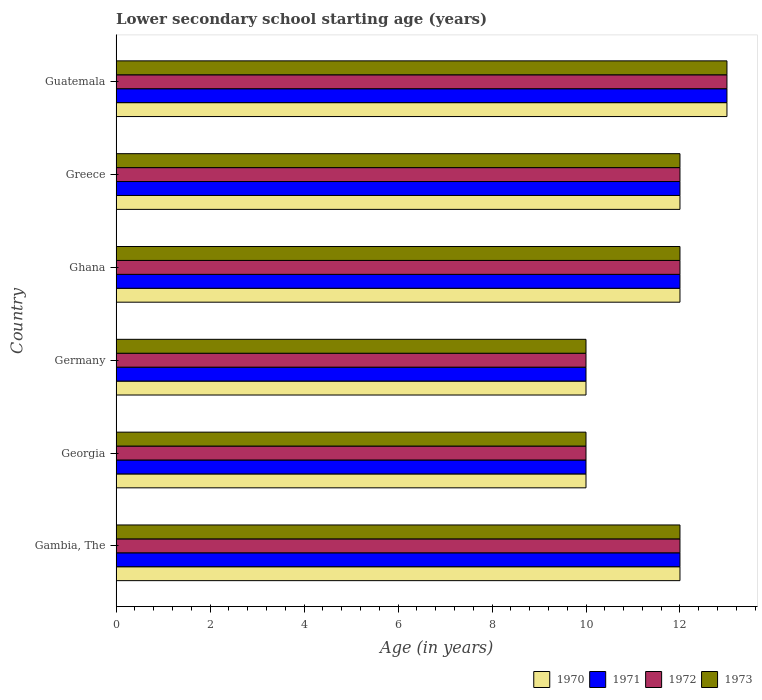How many different coloured bars are there?
Ensure brevity in your answer.  4. Are the number of bars per tick equal to the number of legend labels?
Offer a very short reply. Yes. Are the number of bars on each tick of the Y-axis equal?
Keep it short and to the point. Yes. How many bars are there on the 6th tick from the top?
Offer a terse response. 4. In how many cases, is the number of bars for a given country not equal to the number of legend labels?
Provide a short and direct response. 0. What is the lower secondary school starting age of children in 1970 in Germany?
Your answer should be compact. 10. Across all countries, what is the maximum lower secondary school starting age of children in 1973?
Make the answer very short. 13. Across all countries, what is the minimum lower secondary school starting age of children in 1971?
Keep it short and to the point. 10. In which country was the lower secondary school starting age of children in 1972 maximum?
Provide a short and direct response. Guatemala. In which country was the lower secondary school starting age of children in 1970 minimum?
Give a very brief answer. Georgia. What is the total lower secondary school starting age of children in 1972 in the graph?
Your answer should be compact. 69. What is the difference between the lower secondary school starting age of children in 1970 in Gambia, The and that in Guatemala?
Provide a short and direct response. -1. What is the difference between the lower secondary school starting age of children in 1973 in Georgia and the lower secondary school starting age of children in 1970 in Gambia, The?
Provide a succinct answer. -2. What is the ratio of the lower secondary school starting age of children in 1972 in Ghana to that in Guatemala?
Your response must be concise. 0.92. Is the difference between the lower secondary school starting age of children in 1973 in Germany and Greece greater than the difference between the lower secondary school starting age of children in 1971 in Germany and Greece?
Provide a succinct answer. No. Is the sum of the lower secondary school starting age of children in 1973 in Gambia, The and Ghana greater than the maximum lower secondary school starting age of children in 1970 across all countries?
Ensure brevity in your answer.  Yes. Is it the case that in every country, the sum of the lower secondary school starting age of children in 1972 and lower secondary school starting age of children in 1971 is greater than the lower secondary school starting age of children in 1970?
Provide a succinct answer. Yes. Are all the bars in the graph horizontal?
Ensure brevity in your answer.  Yes. Does the graph contain grids?
Give a very brief answer. No. How many legend labels are there?
Offer a very short reply. 4. What is the title of the graph?
Make the answer very short. Lower secondary school starting age (years). Does "1992" appear as one of the legend labels in the graph?
Keep it short and to the point. No. What is the label or title of the X-axis?
Keep it short and to the point. Age (in years). What is the label or title of the Y-axis?
Your answer should be very brief. Country. What is the Age (in years) in 1970 in Gambia, The?
Your answer should be compact. 12. What is the Age (in years) in 1972 in Gambia, The?
Offer a terse response. 12. What is the Age (in years) of 1970 in Georgia?
Your response must be concise. 10. What is the Age (in years) of 1971 in Georgia?
Give a very brief answer. 10. What is the Age (in years) of 1970 in Germany?
Provide a succinct answer. 10. What is the Age (in years) in 1973 in Ghana?
Provide a succinct answer. 12. What is the Age (in years) of 1972 in Greece?
Provide a short and direct response. 12. What is the Age (in years) of 1971 in Guatemala?
Give a very brief answer. 13. What is the Age (in years) in 1972 in Guatemala?
Offer a terse response. 13. What is the Age (in years) in 1973 in Guatemala?
Your answer should be compact. 13. Across all countries, what is the maximum Age (in years) in 1970?
Give a very brief answer. 13. Across all countries, what is the maximum Age (in years) of 1973?
Your response must be concise. 13. Across all countries, what is the minimum Age (in years) in 1972?
Provide a short and direct response. 10. What is the total Age (in years) in 1970 in the graph?
Give a very brief answer. 69. What is the total Age (in years) in 1971 in the graph?
Make the answer very short. 69. What is the total Age (in years) of 1972 in the graph?
Offer a very short reply. 69. What is the total Age (in years) of 1973 in the graph?
Provide a succinct answer. 69. What is the difference between the Age (in years) in 1970 in Gambia, The and that in Georgia?
Offer a terse response. 2. What is the difference between the Age (in years) in 1971 in Gambia, The and that in Georgia?
Make the answer very short. 2. What is the difference between the Age (in years) in 1972 in Gambia, The and that in Georgia?
Provide a short and direct response. 2. What is the difference between the Age (in years) of 1973 in Gambia, The and that in Georgia?
Provide a succinct answer. 2. What is the difference between the Age (in years) of 1970 in Gambia, The and that in Germany?
Your response must be concise. 2. What is the difference between the Age (in years) in 1971 in Gambia, The and that in Germany?
Ensure brevity in your answer.  2. What is the difference between the Age (in years) in 1973 in Gambia, The and that in Germany?
Offer a very short reply. 2. What is the difference between the Age (in years) in 1970 in Gambia, The and that in Ghana?
Give a very brief answer. 0. What is the difference between the Age (in years) of 1971 in Gambia, The and that in Ghana?
Provide a short and direct response. 0. What is the difference between the Age (in years) in 1970 in Gambia, The and that in Greece?
Offer a terse response. 0. What is the difference between the Age (in years) in 1970 in Gambia, The and that in Guatemala?
Give a very brief answer. -1. What is the difference between the Age (in years) of 1972 in Gambia, The and that in Guatemala?
Your answer should be compact. -1. What is the difference between the Age (in years) in 1970 in Georgia and that in Germany?
Provide a short and direct response. 0. What is the difference between the Age (in years) in 1971 in Georgia and that in Germany?
Offer a terse response. 0. What is the difference between the Age (in years) of 1970 in Georgia and that in Ghana?
Your answer should be very brief. -2. What is the difference between the Age (in years) in 1972 in Georgia and that in Ghana?
Your answer should be very brief. -2. What is the difference between the Age (in years) of 1970 in Georgia and that in Greece?
Ensure brevity in your answer.  -2. What is the difference between the Age (in years) of 1971 in Georgia and that in Greece?
Provide a succinct answer. -2. What is the difference between the Age (in years) of 1972 in Georgia and that in Greece?
Offer a very short reply. -2. What is the difference between the Age (in years) of 1973 in Georgia and that in Greece?
Keep it short and to the point. -2. What is the difference between the Age (in years) of 1970 in Georgia and that in Guatemala?
Provide a short and direct response. -3. What is the difference between the Age (in years) of 1971 in Georgia and that in Guatemala?
Your response must be concise. -3. What is the difference between the Age (in years) in 1972 in Germany and that in Ghana?
Provide a succinct answer. -2. What is the difference between the Age (in years) in 1973 in Germany and that in Ghana?
Offer a very short reply. -2. What is the difference between the Age (in years) of 1972 in Germany and that in Guatemala?
Make the answer very short. -3. What is the difference between the Age (in years) of 1972 in Ghana and that in Greece?
Provide a short and direct response. 0. What is the difference between the Age (in years) of 1970 in Ghana and that in Guatemala?
Offer a very short reply. -1. What is the difference between the Age (in years) of 1973 in Ghana and that in Guatemala?
Your response must be concise. -1. What is the difference between the Age (in years) in 1970 in Greece and that in Guatemala?
Ensure brevity in your answer.  -1. What is the difference between the Age (in years) of 1971 in Greece and that in Guatemala?
Offer a very short reply. -1. What is the difference between the Age (in years) of 1972 in Greece and that in Guatemala?
Provide a short and direct response. -1. What is the difference between the Age (in years) of 1970 in Gambia, The and the Age (in years) of 1971 in Georgia?
Provide a succinct answer. 2. What is the difference between the Age (in years) of 1970 in Gambia, The and the Age (in years) of 1973 in Georgia?
Your answer should be very brief. 2. What is the difference between the Age (in years) of 1971 in Gambia, The and the Age (in years) of 1973 in Georgia?
Make the answer very short. 2. What is the difference between the Age (in years) of 1970 in Gambia, The and the Age (in years) of 1973 in Germany?
Your response must be concise. 2. What is the difference between the Age (in years) of 1971 in Gambia, The and the Age (in years) of 1972 in Germany?
Give a very brief answer. 2. What is the difference between the Age (in years) in 1971 in Gambia, The and the Age (in years) in 1973 in Germany?
Offer a very short reply. 2. What is the difference between the Age (in years) of 1971 in Gambia, The and the Age (in years) of 1972 in Ghana?
Keep it short and to the point. 0. What is the difference between the Age (in years) of 1971 in Gambia, The and the Age (in years) of 1973 in Ghana?
Give a very brief answer. 0. What is the difference between the Age (in years) of 1970 in Gambia, The and the Age (in years) of 1971 in Greece?
Offer a very short reply. 0. What is the difference between the Age (in years) in 1971 in Gambia, The and the Age (in years) in 1972 in Greece?
Ensure brevity in your answer.  0. What is the difference between the Age (in years) of 1970 in Gambia, The and the Age (in years) of 1971 in Guatemala?
Your answer should be compact. -1. What is the difference between the Age (in years) in 1970 in Gambia, The and the Age (in years) in 1972 in Guatemala?
Offer a very short reply. -1. What is the difference between the Age (in years) of 1970 in Gambia, The and the Age (in years) of 1973 in Guatemala?
Your answer should be very brief. -1. What is the difference between the Age (in years) in 1971 in Gambia, The and the Age (in years) in 1972 in Guatemala?
Provide a succinct answer. -1. What is the difference between the Age (in years) in 1971 in Gambia, The and the Age (in years) in 1973 in Guatemala?
Your answer should be very brief. -1. What is the difference between the Age (in years) in 1970 in Georgia and the Age (in years) in 1971 in Germany?
Provide a short and direct response. 0. What is the difference between the Age (in years) in 1971 in Georgia and the Age (in years) in 1972 in Germany?
Your answer should be compact. 0. What is the difference between the Age (in years) of 1971 in Georgia and the Age (in years) of 1973 in Germany?
Make the answer very short. 0. What is the difference between the Age (in years) of 1972 in Georgia and the Age (in years) of 1973 in Germany?
Your answer should be compact. 0. What is the difference between the Age (in years) in 1970 in Georgia and the Age (in years) in 1973 in Ghana?
Give a very brief answer. -2. What is the difference between the Age (in years) of 1971 in Georgia and the Age (in years) of 1972 in Ghana?
Provide a short and direct response. -2. What is the difference between the Age (in years) in 1970 in Georgia and the Age (in years) in 1971 in Greece?
Make the answer very short. -2. What is the difference between the Age (in years) in 1970 in Georgia and the Age (in years) in 1973 in Greece?
Provide a succinct answer. -2. What is the difference between the Age (in years) of 1971 in Georgia and the Age (in years) of 1972 in Greece?
Offer a terse response. -2. What is the difference between the Age (in years) of 1972 in Georgia and the Age (in years) of 1973 in Greece?
Your answer should be compact. -2. What is the difference between the Age (in years) of 1971 in Georgia and the Age (in years) of 1972 in Guatemala?
Make the answer very short. -3. What is the difference between the Age (in years) of 1972 in Georgia and the Age (in years) of 1973 in Guatemala?
Provide a short and direct response. -3. What is the difference between the Age (in years) in 1970 in Germany and the Age (in years) in 1971 in Ghana?
Provide a succinct answer. -2. What is the difference between the Age (in years) in 1971 in Germany and the Age (in years) in 1972 in Ghana?
Ensure brevity in your answer.  -2. What is the difference between the Age (in years) in 1972 in Germany and the Age (in years) in 1973 in Ghana?
Ensure brevity in your answer.  -2. What is the difference between the Age (in years) of 1970 in Germany and the Age (in years) of 1972 in Greece?
Ensure brevity in your answer.  -2. What is the difference between the Age (in years) of 1970 in Germany and the Age (in years) of 1973 in Greece?
Ensure brevity in your answer.  -2. What is the difference between the Age (in years) in 1971 in Germany and the Age (in years) in 1973 in Greece?
Your answer should be very brief. -2. What is the difference between the Age (in years) in 1972 in Germany and the Age (in years) in 1973 in Greece?
Make the answer very short. -2. What is the difference between the Age (in years) in 1972 in Germany and the Age (in years) in 1973 in Guatemala?
Your answer should be compact. -3. What is the difference between the Age (in years) of 1970 in Ghana and the Age (in years) of 1973 in Greece?
Your response must be concise. 0. What is the difference between the Age (in years) of 1971 in Ghana and the Age (in years) of 1973 in Greece?
Make the answer very short. 0. What is the difference between the Age (in years) of 1970 in Ghana and the Age (in years) of 1972 in Guatemala?
Offer a terse response. -1. What is the difference between the Age (in years) in 1970 in Ghana and the Age (in years) in 1973 in Guatemala?
Provide a succinct answer. -1. What is the difference between the Age (in years) of 1970 in Greece and the Age (in years) of 1971 in Guatemala?
Offer a terse response. -1. What is the difference between the Age (in years) in 1972 in Greece and the Age (in years) in 1973 in Guatemala?
Your answer should be very brief. -1. What is the average Age (in years) in 1971 per country?
Ensure brevity in your answer.  11.5. What is the average Age (in years) of 1973 per country?
Provide a short and direct response. 11.5. What is the difference between the Age (in years) in 1970 and Age (in years) in 1971 in Gambia, The?
Provide a short and direct response. 0. What is the difference between the Age (in years) of 1970 and Age (in years) of 1972 in Gambia, The?
Your response must be concise. 0. What is the difference between the Age (in years) of 1971 and Age (in years) of 1972 in Gambia, The?
Make the answer very short. 0. What is the difference between the Age (in years) of 1972 and Age (in years) of 1973 in Gambia, The?
Provide a succinct answer. 0. What is the difference between the Age (in years) of 1970 and Age (in years) of 1971 in Georgia?
Provide a succinct answer. 0. What is the difference between the Age (in years) in 1972 and Age (in years) in 1973 in Georgia?
Your answer should be compact. 0. What is the difference between the Age (in years) in 1970 and Age (in years) in 1971 in Germany?
Offer a terse response. 0. What is the difference between the Age (in years) of 1970 and Age (in years) of 1973 in Germany?
Make the answer very short. 0. What is the difference between the Age (in years) in 1971 and Age (in years) in 1972 in Germany?
Keep it short and to the point. 0. What is the difference between the Age (in years) of 1970 and Age (in years) of 1971 in Ghana?
Ensure brevity in your answer.  0. What is the difference between the Age (in years) in 1970 and Age (in years) in 1973 in Ghana?
Offer a very short reply. 0. What is the difference between the Age (in years) of 1971 and Age (in years) of 1972 in Ghana?
Provide a succinct answer. 0. What is the difference between the Age (in years) of 1971 and Age (in years) of 1973 in Ghana?
Your answer should be very brief. 0. What is the difference between the Age (in years) in 1970 and Age (in years) in 1971 in Greece?
Make the answer very short. 0. What is the difference between the Age (in years) of 1970 and Age (in years) of 1972 in Greece?
Your answer should be very brief. 0. What is the difference between the Age (in years) in 1970 and Age (in years) in 1973 in Greece?
Ensure brevity in your answer.  0. What is the difference between the Age (in years) in 1971 and Age (in years) in 1973 in Greece?
Make the answer very short. 0. What is the difference between the Age (in years) of 1972 and Age (in years) of 1973 in Greece?
Give a very brief answer. 0. What is the difference between the Age (in years) of 1970 and Age (in years) of 1972 in Guatemala?
Make the answer very short. 0. What is the difference between the Age (in years) of 1970 and Age (in years) of 1973 in Guatemala?
Ensure brevity in your answer.  0. What is the ratio of the Age (in years) of 1970 in Gambia, The to that in Georgia?
Give a very brief answer. 1.2. What is the ratio of the Age (in years) in 1973 in Gambia, The to that in Georgia?
Ensure brevity in your answer.  1.2. What is the ratio of the Age (in years) in 1970 in Gambia, The to that in Germany?
Offer a terse response. 1.2. What is the ratio of the Age (in years) of 1971 in Gambia, The to that in Germany?
Make the answer very short. 1.2. What is the ratio of the Age (in years) in 1970 in Gambia, The to that in Ghana?
Your response must be concise. 1. What is the ratio of the Age (in years) of 1971 in Gambia, The to that in Ghana?
Your answer should be very brief. 1. What is the ratio of the Age (in years) of 1970 in Gambia, The to that in Greece?
Provide a short and direct response. 1. What is the ratio of the Age (in years) of 1972 in Gambia, The to that in Greece?
Your answer should be very brief. 1. What is the ratio of the Age (in years) in 1970 in Gambia, The to that in Guatemala?
Your response must be concise. 0.92. What is the ratio of the Age (in years) of 1971 in Gambia, The to that in Guatemala?
Offer a very short reply. 0.92. What is the ratio of the Age (in years) in 1972 in Gambia, The to that in Guatemala?
Offer a very short reply. 0.92. What is the ratio of the Age (in years) in 1971 in Georgia to that in Germany?
Offer a terse response. 1. What is the ratio of the Age (in years) in 1972 in Georgia to that in Germany?
Offer a very short reply. 1. What is the ratio of the Age (in years) of 1973 in Georgia to that in Germany?
Provide a succinct answer. 1. What is the ratio of the Age (in years) of 1971 in Georgia to that in Ghana?
Offer a very short reply. 0.83. What is the ratio of the Age (in years) of 1970 in Georgia to that in Greece?
Offer a terse response. 0.83. What is the ratio of the Age (in years) of 1971 in Georgia to that in Greece?
Ensure brevity in your answer.  0.83. What is the ratio of the Age (in years) in 1972 in Georgia to that in Greece?
Keep it short and to the point. 0.83. What is the ratio of the Age (in years) in 1970 in Georgia to that in Guatemala?
Give a very brief answer. 0.77. What is the ratio of the Age (in years) in 1971 in Georgia to that in Guatemala?
Provide a short and direct response. 0.77. What is the ratio of the Age (in years) of 1972 in Georgia to that in Guatemala?
Your response must be concise. 0.77. What is the ratio of the Age (in years) of 1973 in Georgia to that in Guatemala?
Provide a short and direct response. 0.77. What is the ratio of the Age (in years) of 1972 in Germany to that in Ghana?
Offer a terse response. 0.83. What is the ratio of the Age (in years) of 1970 in Germany to that in Greece?
Provide a succinct answer. 0.83. What is the ratio of the Age (in years) of 1971 in Germany to that in Greece?
Give a very brief answer. 0.83. What is the ratio of the Age (in years) of 1970 in Germany to that in Guatemala?
Offer a terse response. 0.77. What is the ratio of the Age (in years) in 1971 in Germany to that in Guatemala?
Provide a short and direct response. 0.77. What is the ratio of the Age (in years) in 1972 in Germany to that in Guatemala?
Your answer should be compact. 0.77. What is the ratio of the Age (in years) in 1973 in Germany to that in Guatemala?
Keep it short and to the point. 0.77. What is the ratio of the Age (in years) in 1972 in Ghana to that in Guatemala?
Offer a very short reply. 0.92. What is the ratio of the Age (in years) of 1973 in Ghana to that in Guatemala?
Offer a very short reply. 0.92. What is the ratio of the Age (in years) of 1971 in Greece to that in Guatemala?
Ensure brevity in your answer.  0.92. What is the ratio of the Age (in years) of 1973 in Greece to that in Guatemala?
Offer a terse response. 0.92. What is the difference between the highest and the second highest Age (in years) of 1971?
Your response must be concise. 1. What is the difference between the highest and the second highest Age (in years) in 1972?
Your answer should be compact. 1. What is the difference between the highest and the lowest Age (in years) of 1970?
Provide a short and direct response. 3. What is the difference between the highest and the lowest Age (in years) in 1971?
Your response must be concise. 3. What is the difference between the highest and the lowest Age (in years) of 1972?
Offer a very short reply. 3. 